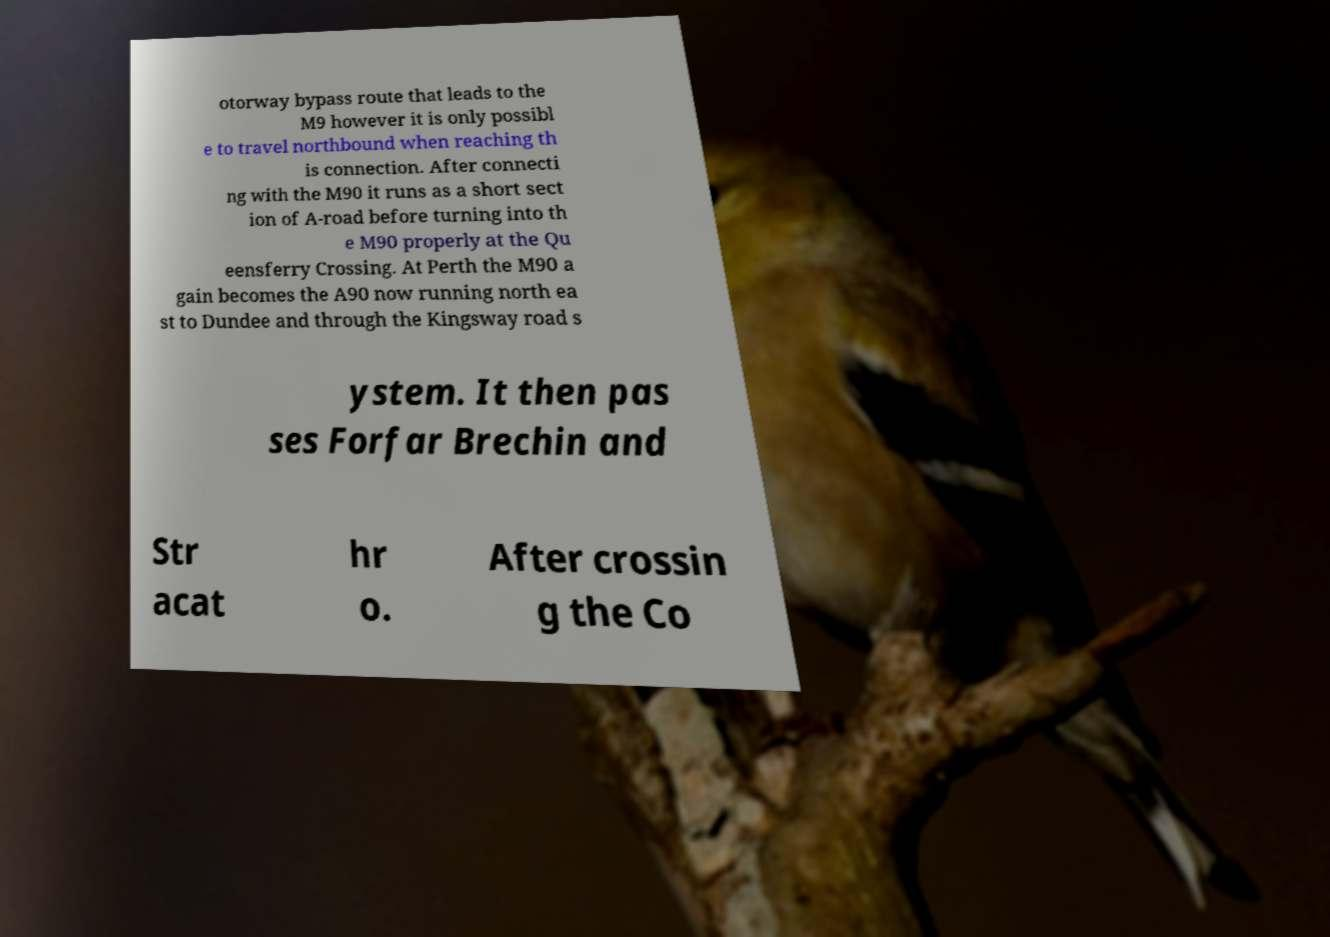Can you read and provide the text displayed in the image?This photo seems to have some interesting text. Can you extract and type it out for me? otorway bypass route that leads to the M9 however it is only possibl e to travel northbound when reaching th is connection. After connecti ng with the M90 it runs as a short sect ion of A-road before turning into th e M90 properly at the Qu eensferry Crossing. At Perth the M90 a gain becomes the A90 now running north ea st to Dundee and through the Kingsway road s ystem. It then pas ses Forfar Brechin and Str acat hr o. After crossin g the Co 